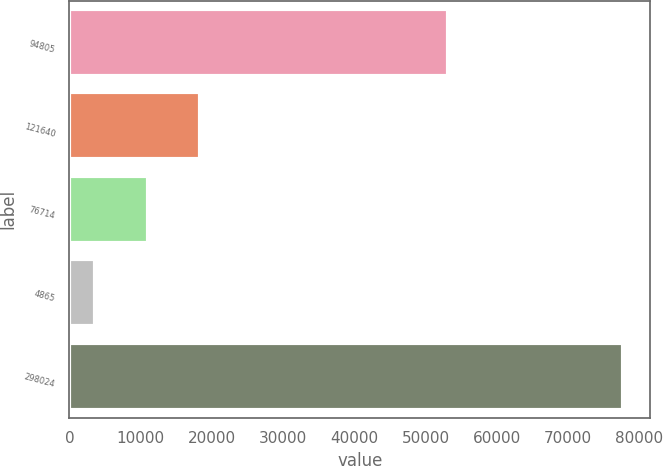Convert chart. <chart><loc_0><loc_0><loc_500><loc_500><bar_chart><fcel>94805<fcel>121640<fcel>76714<fcel>4865<fcel>298024<nl><fcel>53140<fcel>18401.4<fcel>10989.2<fcel>3577<fcel>77699<nl></chart> 